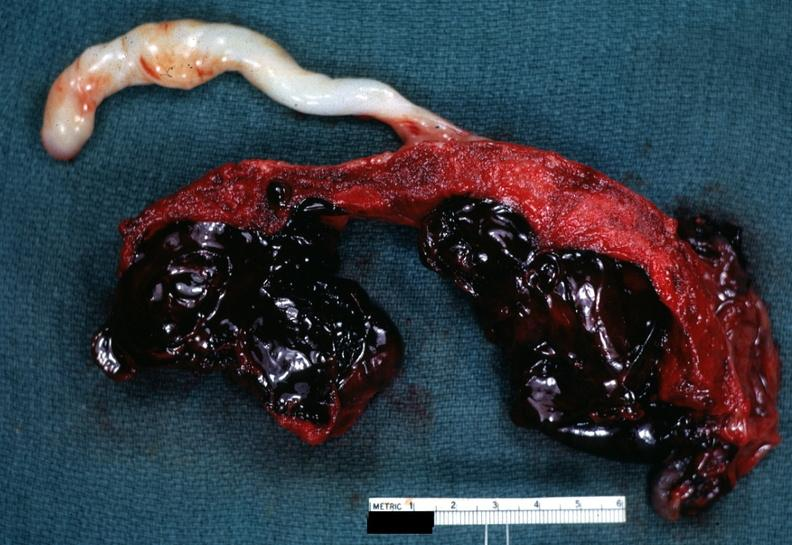does spina bifida show saggital section which is a very good illustration of this lesion?
Answer the question using a single word or phrase. No 